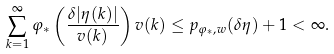<formula> <loc_0><loc_0><loc_500><loc_500>\sum _ { k = 1 } ^ { \infty } \varphi _ { * } \left ( \frac { \delta | \eta ( k ) | } { v ( k ) } \right ) v ( k ) \leq p _ { \varphi _ { * } , w } ( \delta \eta ) + 1 < \infty .</formula> 